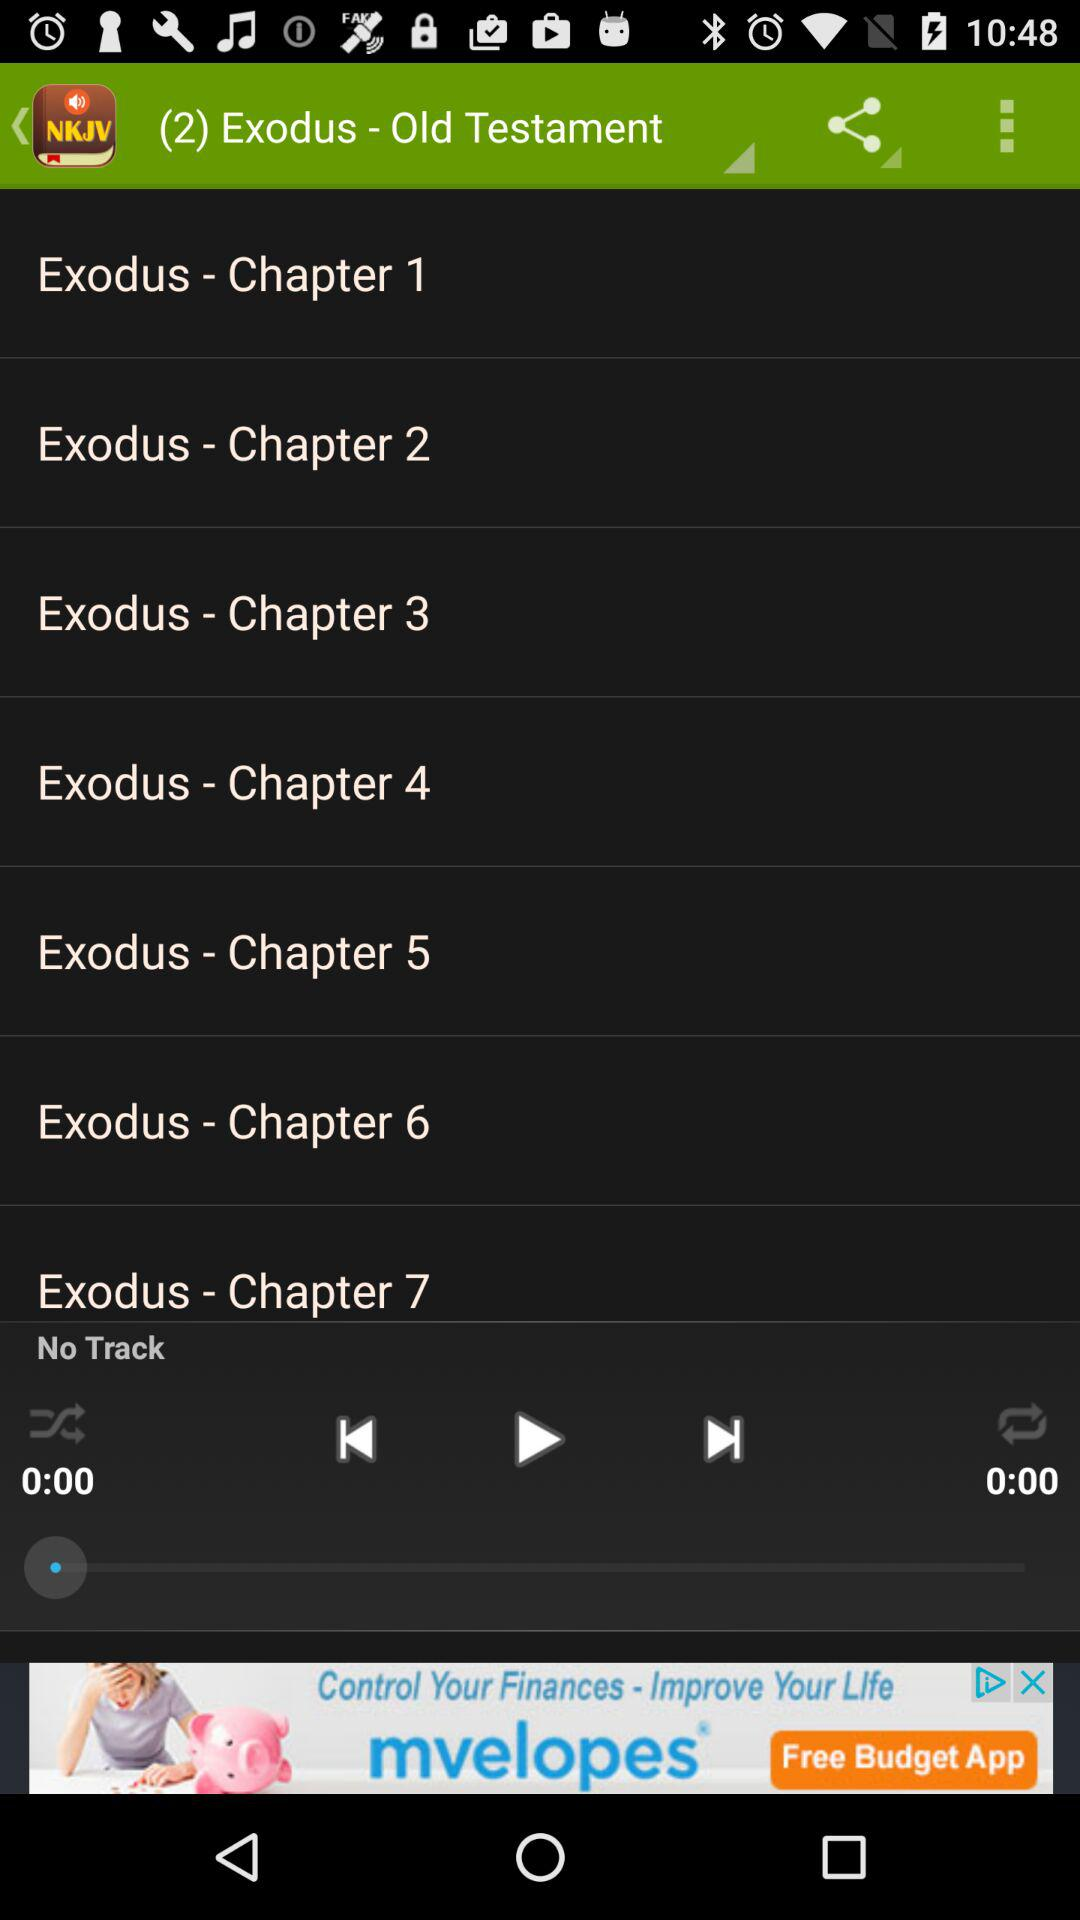What is the name of the application? The name of the application is "NKJV Audio Bible". 